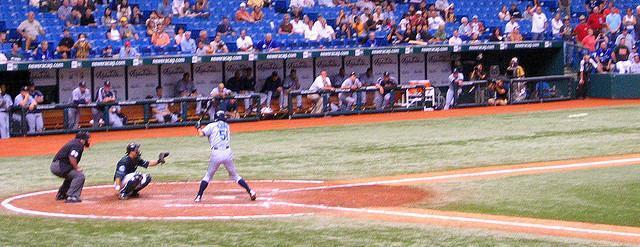How many planes have orange tail sections?
Give a very brief answer. 0. 